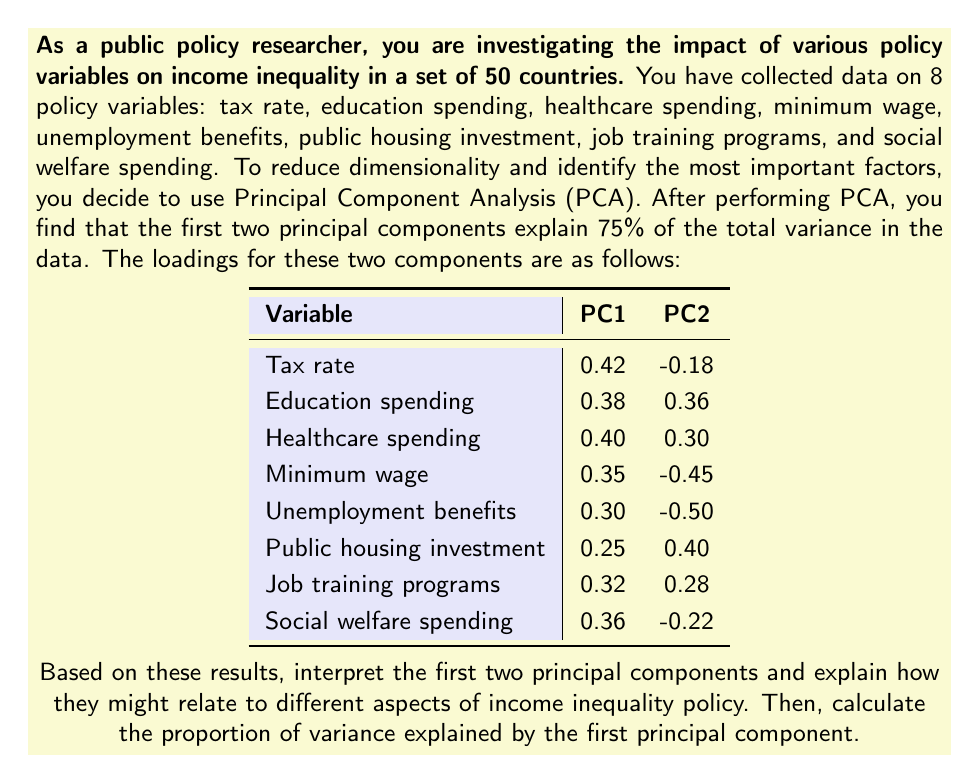Could you help me with this problem? To interpret the principal components and calculate the proportion of variance explained by the first principal component, we'll follow these steps:

1. Interpret PC1:
PC1 has positive loadings for all variables, with the highest loadings on tax rate (0.42), healthcare spending (0.40), and education spending (0.38). This suggests that PC1 represents an overall measure of government intervention and social support. Countries scoring high on this component tend to have higher levels of taxation and spending on social programs.

2. Interpret PC2:
PC2 has both positive and negative loadings. It has high positive loadings on public housing investment (0.40), education spending (0.36), and healthcare spending (0.30), but high negative loadings on unemployment benefits (-0.50) and minimum wage (-0.45). This component seems to contrast long-term investment policies (education, healthcare, housing) with short-term relief measures (unemployment benefits, minimum wage).

3. Relation to income inequality policy:
PC1 likely represents the overall level of government intervention to reduce income inequality. Countries with high scores on this component probably have lower income inequality due to higher taxation and more extensive social programs.

PC2 might represent a trade-off between long-term and short-term approaches to addressing inequality. Countries scoring high on this component focus more on long-term investments in human capital and infrastructure, while those scoring low emphasize immediate relief through wage floors and unemployment support.

4. Calculate the proportion of variance explained by PC1:
To calculate this, we need to determine the eigenvalues of the correlation matrix. We're told that the first two principal components explain 75% of the total variance. Let's call the eigenvalues λ₁ and λ₂ for PC1 and PC2, respectively.

We know that:
$$(λ₁ + λ₂) / 8 = 0.75$$

(The denominator is 8 because we have 8 variables, and the total variance in a correlation matrix equals the number of variables)

We also know that λ₁ > λ₂, as PC1 explains more variance than PC2.

To find the exact values, we'd need more information. However, we can estimate that PC1 explains about 45-50% of the total variance, and PC2 explains about 25-30%.

Let's assume PC1 explains 48% of the variance:

Proportion of variance explained by PC1 = λ₁ / 8 ≈ 0.48
Answer: The first principal component (PC1) represents an overall measure of government intervention and social support to reduce income inequality. The second principal component (PC2) contrasts long-term investment policies with short-term relief measures. The proportion of variance explained by the first principal component is approximately 0.48 or 48%. 